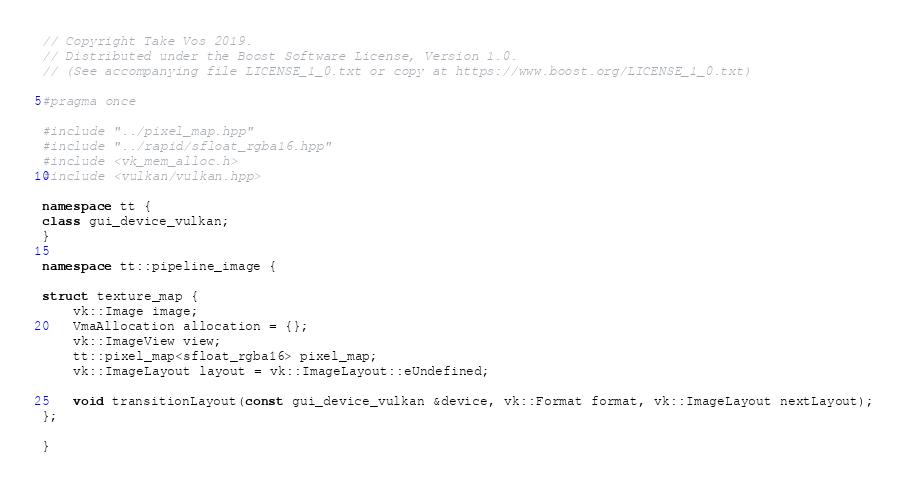<code> <loc_0><loc_0><loc_500><loc_500><_C++_>// Copyright Take Vos 2019.
// Distributed under the Boost Software License, Version 1.0.
// (See accompanying file LICENSE_1_0.txt or copy at https://www.boost.org/LICENSE_1_0.txt)

#pragma once

#include "../pixel_map.hpp"
#include "../rapid/sfloat_rgba16.hpp"
#include <vk_mem_alloc.h>
#include <vulkan/vulkan.hpp>

namespace tt {
class gui_device_vulkan;
}

namespace tt::pipeline_image {

struct texture_map {
    vk::Image image;
    VmaAllocation allocation = {};
    vk::ImageView view;
    tt::pixel_map<sfloat_rgba16> pixel_map;
    vk::ImageLayout layout = vk::ImageLayout::eUndefined;

    void transitionLayout(const gui_device_vulkan &device, vk::Format format, vk::ImageLayout nextLayout);
};

}
</code> 